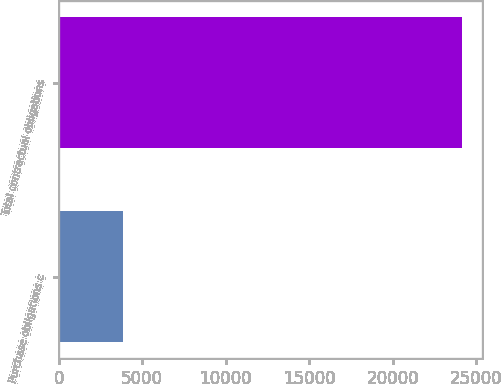Convert chart to OTSL. <chart><loc_0><loc_0><loc_500><loc_500><bar_chart><fcel>Purchase obligations c<fcel>Total contractual obligations<nl><fcel>3820<fcel>24168<nl></chart> 